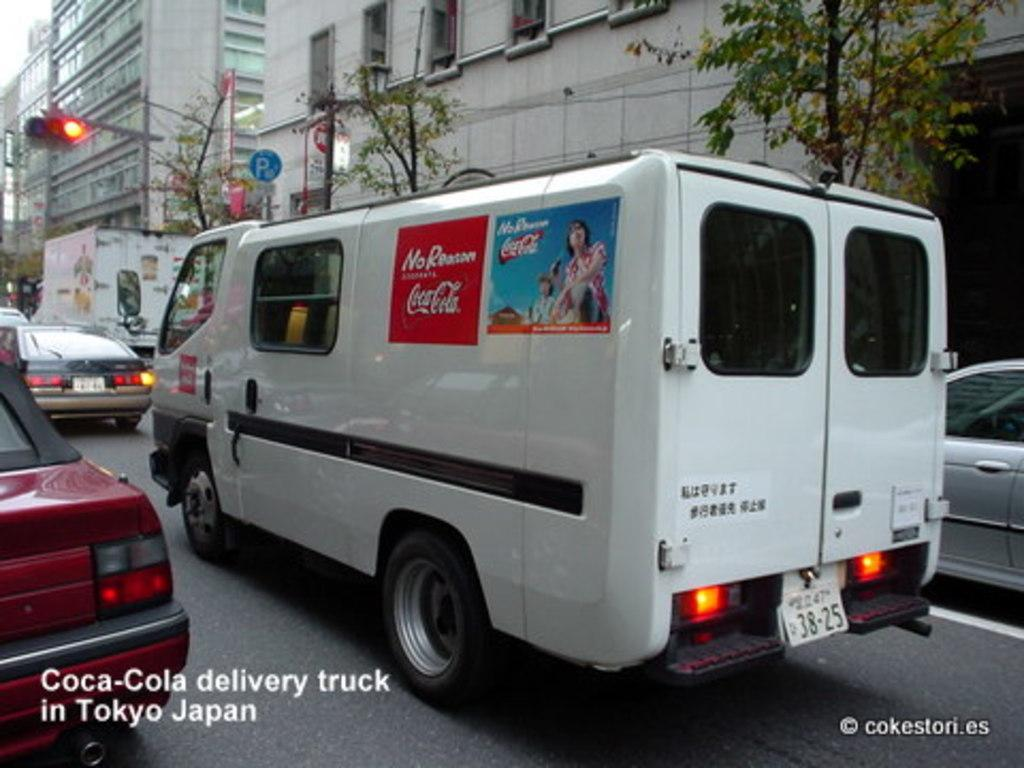<image>
Write a terse but informative summary of the picture. A white delivery van for Coca-Cola sits in traffic. 